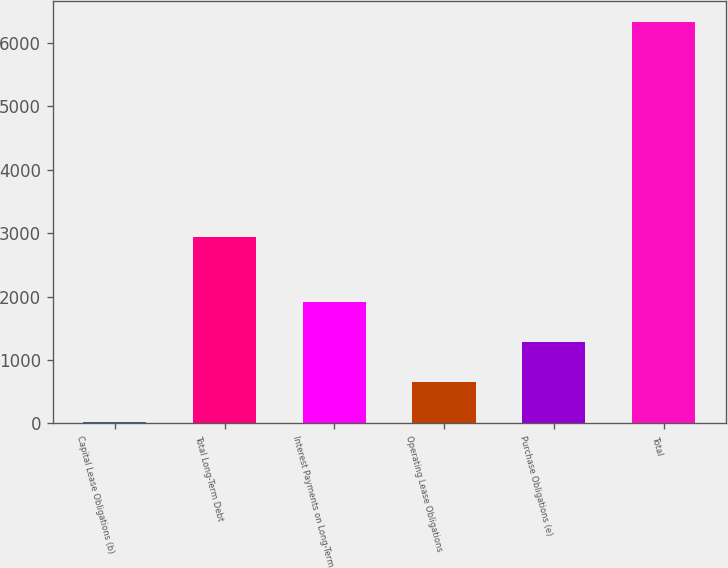Convert chart. <chart><loc_0><loc_0><loc_500><loc_500><bar_chart><fcel>Capital Lease Obligations (b)<fcel>Total Long-Term Debt<fcel>Interest Payments on Long-Term<fcel>Operating Lease Obligations<fcel>Purchase Obligations (e)<fcel>Total<nl><fcel>27.2<fcel>2933.2<fcel>1920.23<fcel>658.21<fcel>1289.22<fcel>6337.3<nl></chart> 